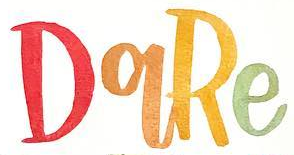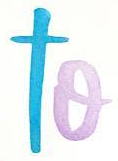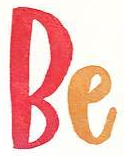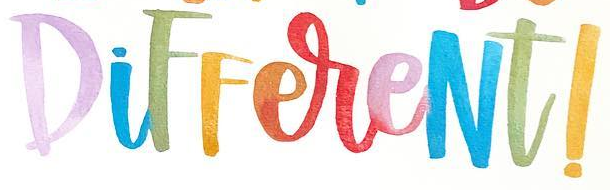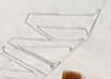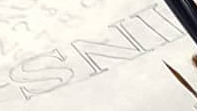What words can you see in these images in sequence, separated by a semicolon? DqRe; to; Be; DiFFereNt!; W; INS 